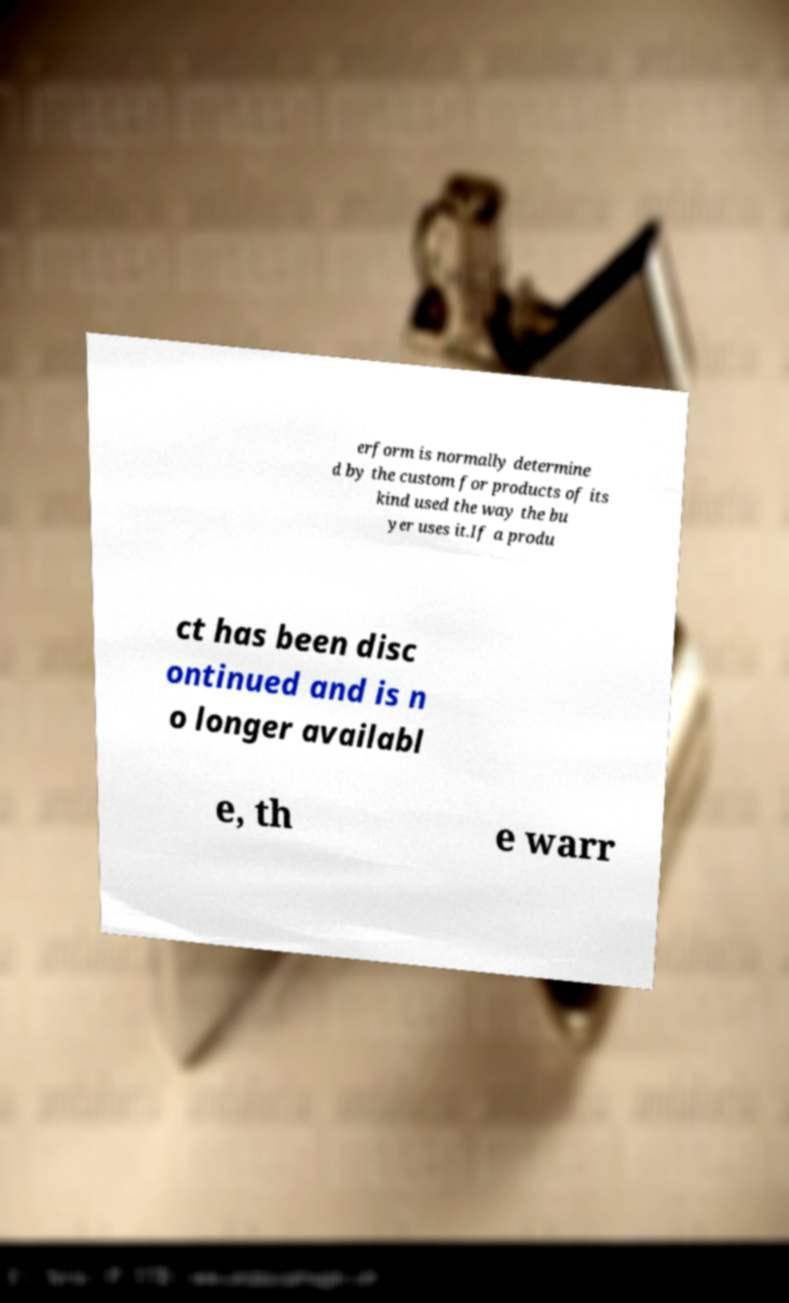There's text embedded in this image that I need extracted. Can you transcribe it verbatim? erform is normally determine d by the custom for products of its kind used the way the bu yer uses it.If a produ ct has been disc ontinued and is n o longer availabl e, th e warr 